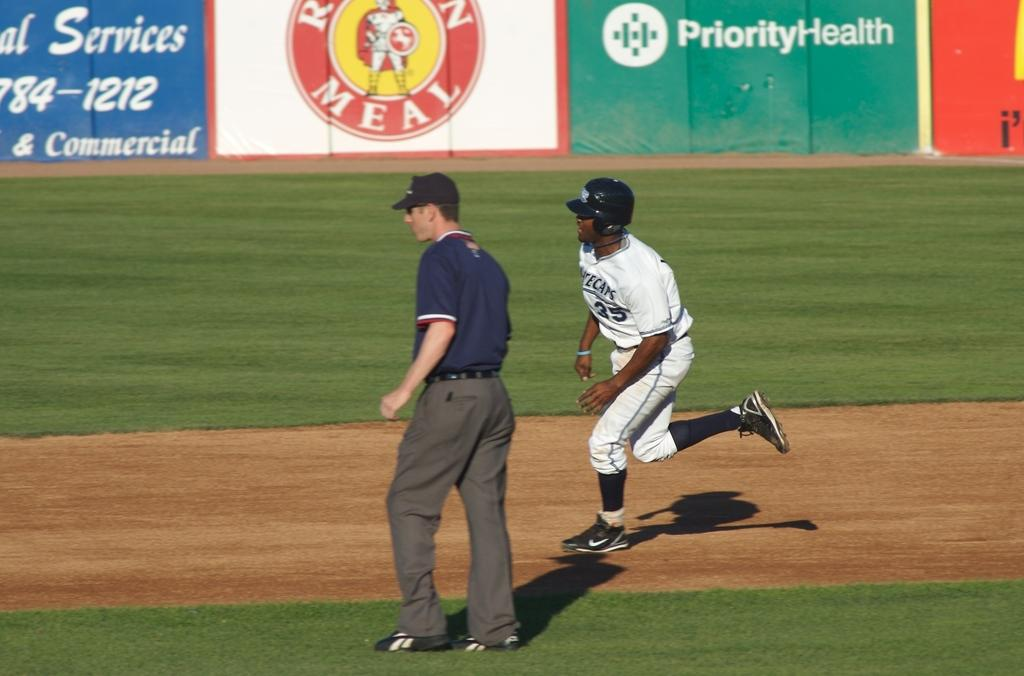<image>
Share a concise interpretation of the image provided. A baseball player is running around a stadium where Priority Health is an advertiser. 